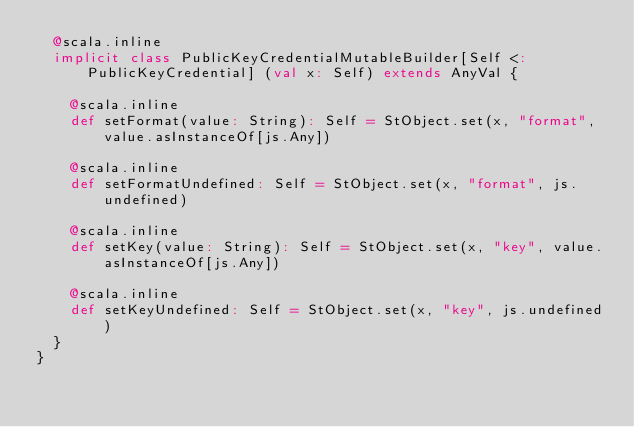Convert code to text. <code><loc_0><loc_0><loc_500><loc_500><_Scala_>  @scala.inline
  implicit class PublicKeyCredentialMutableBuilder[Self <: PublicKeyCredential] (val x: Self) extends AnyVal {
    
    @scala.inline
    def setFormat(value: String): Self = StObject.set(x, "format", value.asInstanceOf[js.Any])
    
    @scala.inline
    def setFormatUndefined: Self = StObject.set(x, "format", js.undefined)
    
    @scala.inline
    def setKey(value: String): Self = StObject.set(x, "key", value.asInstanceOf[js.Any])
    
    @scala.inline
    def setKeyUndefined: Self = StObject.set(x, "key", js.undefined)
  }
}
</code> 